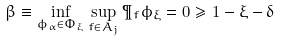Convert formula to latex. <formula><loc_0><loc_0><loc_500><loc_500>\beta \equiv \inf _ { \phi _ { \alpha } \in \Phi _ { \xi } } \sup _ { f \in A _ { j } } \P _ { f } { \phi _ { \xi } = 0 } \geq 1 - \xi - \delta</formula> 